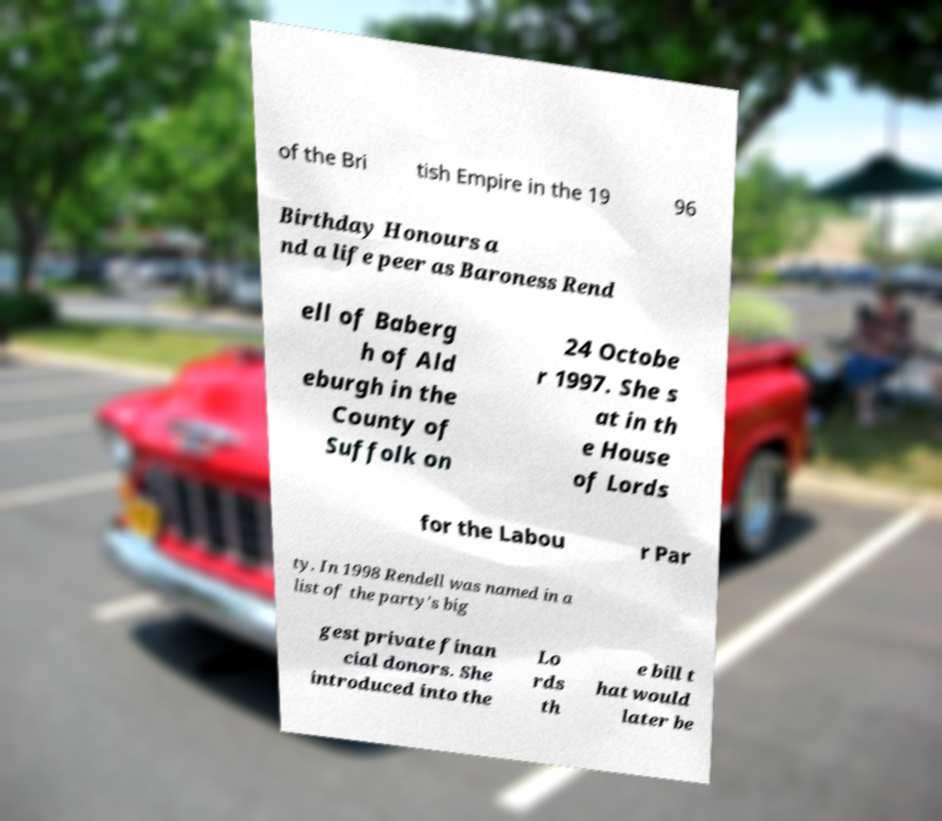Please identify and transcribe the text found in this image. of the Bri tish Empire in the 19 96 Birthday Honours a nd a life peer as Baroness Rend ell of Baberg h of Ald eburgh in the County of Suffolk on 24 Octobe r 1997. She s at in th e House of Lords for the Labou r Par ty. In 1998 Rendell was named in a list of the party's big gest private finan cial donors. She introduced into the Lo rds th e bill t hat would later be 